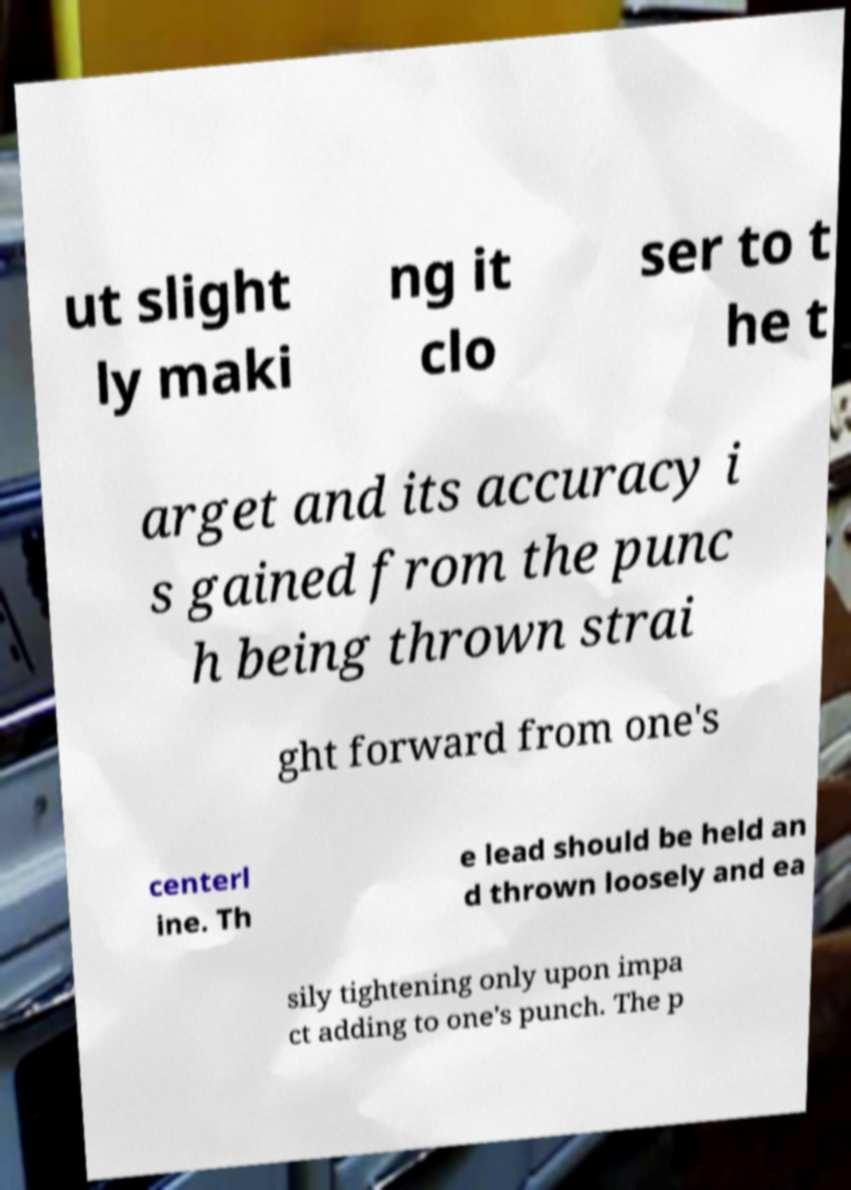Can you read and provide the text displayed in the image?This photo seems to have some interesting text. Can you extract and type it out for me? ut slight ly maki ng it clo ser to t he t arget and its accuracy i s gained from the punc h being thrown strai ght forward from one's centerl ine. Th e lead should be held an d thrown loosely and ea sily tightening only upon impa ct adding to one's punch. The p 